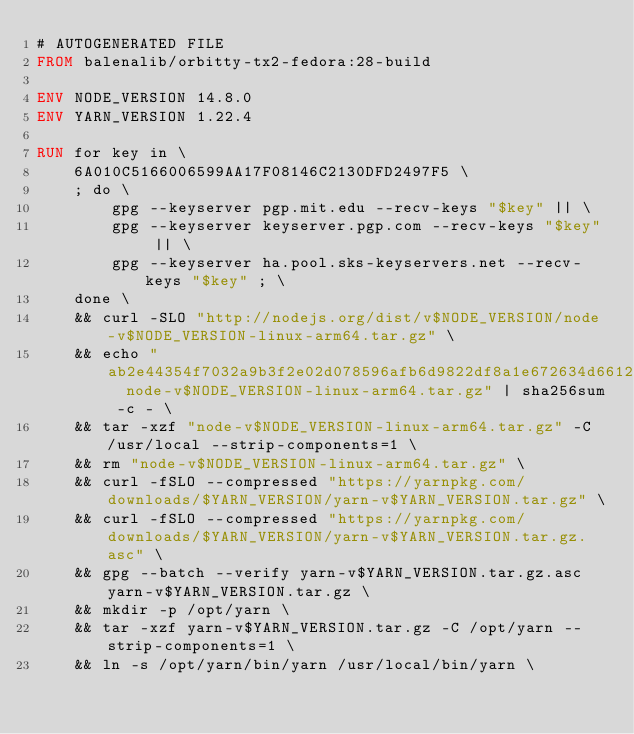<code> <loc_0><loc_0><loc_500><loc_500><_Dockerfile_># AUTOGENERATED FILE
FROM balenalib/orbitty-tx2-fedora:28-build

ENV NODE_VERSION 14.8.0
ENV YARN_VERSION 1.22.4

RUN for key in \
	6A010C5166006599AA17F08146C2130DFD2497F5 \
	; do \
		gpg --keyserver pgp.mit.edu --recv-keys "$key" || \
		gpg --keyserver keyserver.pgp.com --recv-keys "$key" || \
		gpg --keyserver ha.pool.sks-keyservers.net --recv-keys "$key" ; \
	done \
	&& curl -SLO "http://nodejs.org/dist/v$NODE_VERSION/node-v$NODE_VERSION-linux-arm64.tar.gz" \
	&& echo "ab2e44354f7032a9b3f2e02d078596afb6d9822df8a1e672634d66126d17df7a  node-v$NODE_VERSION-linux-arm64.tar.gz" | sha256sum -c - \
	&& tar -xzf "node-v$NODE_VERSION-linux-arm64.tar.gz" -C /usr/local --strip-components=1 \
	&& rm "node-v$NODE_VERSION-linux-arm64.tar.gz" \
	&& curl -fSLO --compressed "https://yarnpkg.com/downloads/$YARN_VERSION/yarn-v$YARN_VERSION.tar.gz" \
	&& curl -fSLO --compressed "https://yarnpkg.com/downloads/$YARN_VERSION/yarn-v$YARN_VERSION.tar.gz.asc" \
	&& gpg --batch --verify yarn-v$YARN_VERSION.tar.gz.asc yarn-v$YARN_VERSION.tar.gz \
	&& mkdir -p /opt/yarn \
	&& tar -xzf yarn-v$YARN_VERSION.tar.gz -C /opt/yarn --strip-components=1 \
	&& ln -s /opt/yarn/bin/yarn /usr/local/bin/yarn \</code> 